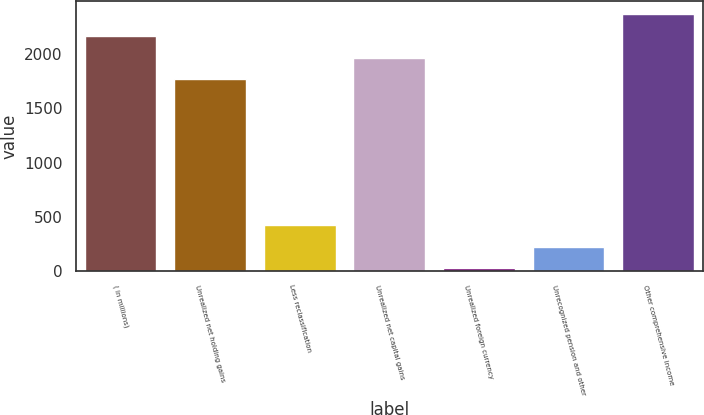<chart> <loc_0><loc_0><loc_500><loc_500><bar_chart><fcel>( in millions)<fcel>Unrealized net holding gains<fcel>Less reclassification<fcel>Unrealized net capital gains<fcel>Unrealized foreign currency<fcel>Unrecognized pension and other<fcel>Other comprehensive income<nl><fcel>2168<fcel>1767<fcel>424<fcel>1967.5<fcel>23<fcel>223.5<fcel>2368.5<nl></chart> 